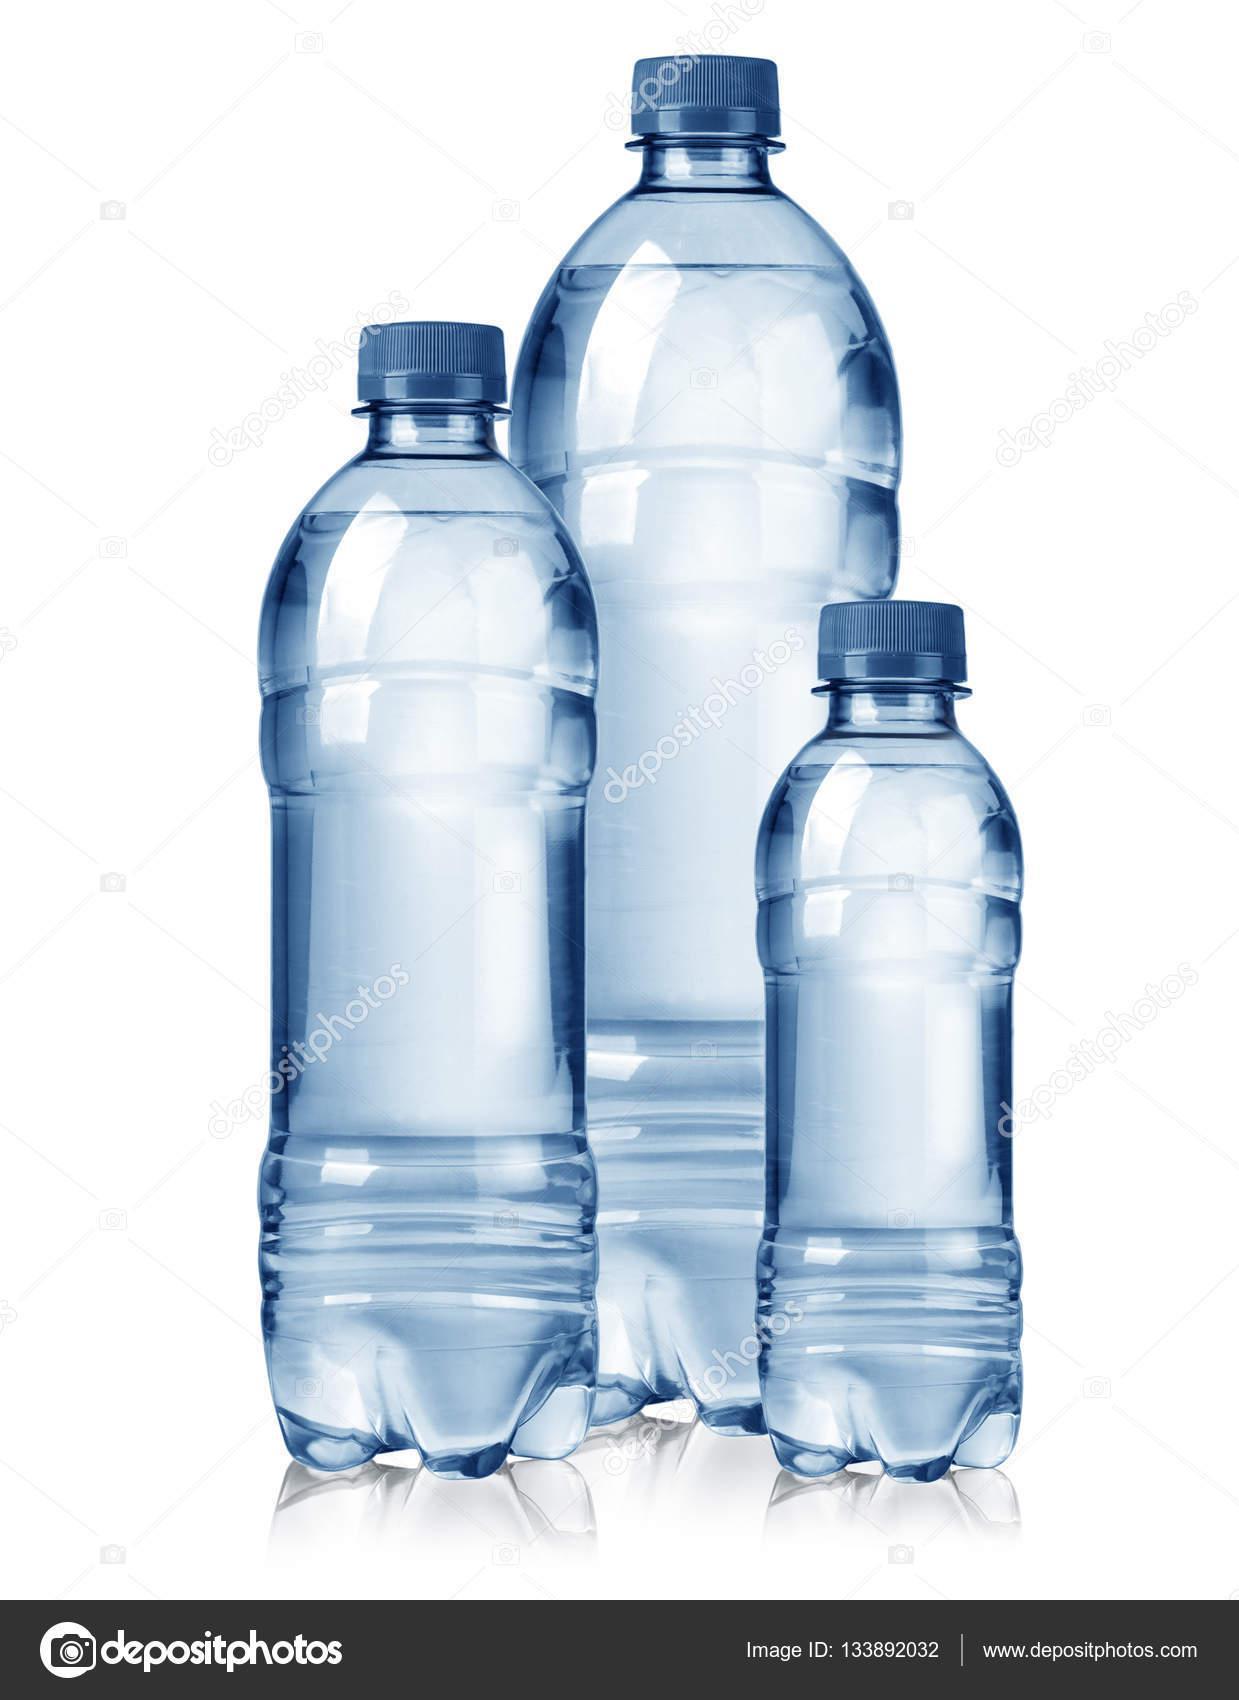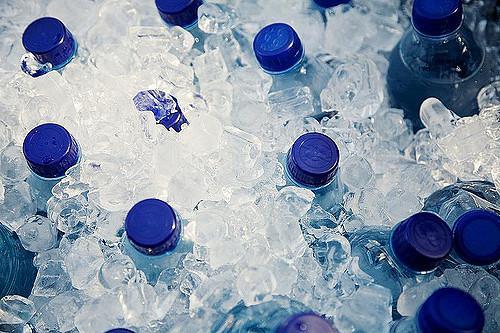The first image is the image on the left, the second image is the image on the right. Assess this claim about the two images: "In at least one image there are three single person sealed water bottles.". Correct or not? Answer yes or no. Yes. The first image is the image on the left, the second image is the image on the right. For the images displayed, is the sentence "All bottles are upright and have lids on them, and at least some bottles have visible labels." factually correct? Answer yes or no. No. 